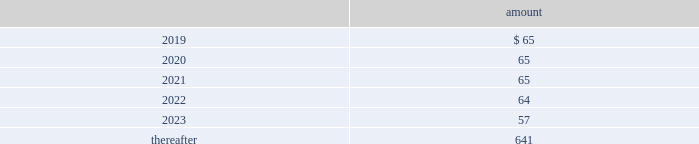Totaled $ 12 million , $ 13 million and $ 9 million for 2018 , 2017 and 2016 , respectively .
All of the company 2019s contributions are invested in one or more funds at the direction of the employees .
Note 16 : commitments and contingencies commitments have been made in connection with certain construction programs .
The estimated capital expenditures required under legal and binding contractual obligations amounted to $ 419 million as of december 31 , 2018 .
The company 2019s regulated subsidiaries maintain agreements with other water purveyors for the purchase of water to supplement their water supply .
The table provides the future annual commitments related to minimum quantities of purchased water having non-cancelable: .
The company enters into agreements for the provision of services to water and wastewater facilities for the united states military , municipalities and other customers .
See note 3 2014revenue recognition for additional information regarding the company 2019s performance obligations .
Contingencies the company is routinely involved in legal actions incident to the normal conduct of its business .
As of december 31 , 2018 , the company has accrued approximately $ 54 million of probable loss contingencies and has estimated that the maximum amount of losses associated with reasonably possible loss contingencies that can be reasonably estimated is $ 26 million .
For certain matters , claims and actions , the company is unable to estimate possible losses .
The company believes that damages or settlements , if any , recovered by plaintiffs in such matters , claims or actions , other than as described in this note 16 2014commitments and contingencies , will not have a material adverse effect on the company .
West virginia elk river freedom industries chemical spill on june 8 , 2018 , the u.s .
District court for the southern district of west virginia granted final approval of a settlement class and global class action settlement ( the 201csettlement 201d ) for all claims and potential claims by all putative class members ( collectively , the 201cplaintiffs 201d ) arising out of the january 2014 freedom industries , inc .
Chemical spill in west virginia .
The effective date of the settlement is july 16 , 2018 .
Under the terms and conditions of the settlement , west virginia-american water company ( 201cwvawc 201d ) and certain other company affiliated entities ( collectively , the 201camerican water defendants 201d ) did not admit , and will not admit , any fault or liability for any of the allegations made by the plaintiffs in any of the actions that were resolved .
Under federal class action rules , claimants had the right , until december 8 , 2017 , to elect to opt out of the final settlement .
Less than 100 of the 225000 estimated putative class members elected to opt out from the settlement , and these claimants will not receive any benefit from or be bound by the terms of the settlement .
In june 2018 , the company and its remaining non-participating general liability insurance carrier settled for a payment to the company of $ 20 million , out of a maximum of $ 25 million in potential coverage under the terms of the relevant policy , in exchange for a full release by the american water defendants of all claims against the insurance carrier related to the freedom industries chemical spill. .
What percentage of future annual commitments related to minimum quantities of purchased water having non-cancelable are due in 2020? 
Rationale: from here you need to take the amount due in 2020 , or 65 , and divide by the total or $ 957 to get 6.8%
Computations: (((65 + 65) + (65 + 64)) + (57 + 641))
Answer: 957.0. 